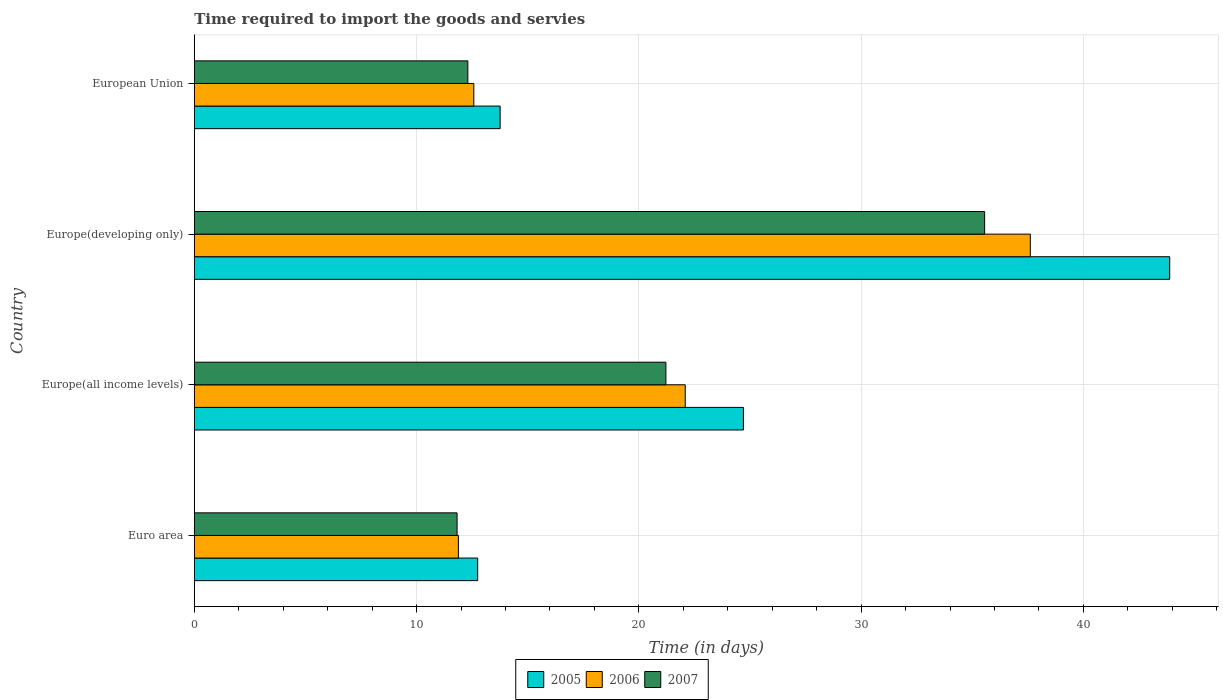Are the number of bars on each tick of the Y-axis equal?
Ensure brevity in your answer.  Yes. How many bars are there on the 1st tick from the bottom?
Your response must be concise. 3. What is the label of the 3rd group of bars from the top?
Your answer should be very brief. Europe(all income levels). In how many cases, is the number of bars for a given country not equal to the number of legend labels?
Provide a succinct answer. 0. What is the number of days required to import the goods and services in 2006 in Euro area?
Provide a succinct answer. 11.88. Across all countries, what is the maximum number of days required to import the goods and services in 2006?
Keep it short and to the point. 37.61. Across all countries, what is the minimum number of days required to import the goods and services in 2007?
Give a very brief answer. 11.82. In which country was the number of days required to import the goods and services in 2007 maximum?
Your answer should be very brief. Europe(developing only). In which country was the number of days required to import the goods and services in 2007 minimum?
Keep it short and to the point. Euro area. What is the total number of days required to import the goods and services in 2006 in the graph?
Provide a succinct answer. 84.16. What is the difference between the number of days required to import the goods and services in 2007 in Euro area and that in Europe(developing only)?
Offer a very short reply. -23.73. What is the difference between the number of days required to import the goods and services in 2006 in Euro area and the number of days required to import the goods and services in 2005 in Europe(all income levels)?
Your response must be concise. -12.82. What is the average number of days required to import the goods and services in 2005 per country?
Make the answer very short. 23.77. What is the difference between the number of days required to import the goods and services in 2007 and number of days required to import the goods and services in 2005 in European Union?
Give a very brief answer. -1.45. In how many countries, is the number of days required to import the goods and services in 2005 greater than 38 days?
Keep it short and to the point. 1. What is the ratio of the number of days required to import the goods and services in 2006 in Euro area to that in Europe(all income levels)?
Offer a terse response. 0.54. Is the difference between the number of days required to import the goods and services in 2007 in Europe(all income levels) and Europe(developing only) greater than the difference between the number of days required to import the goods and services in 2005 in Europe(all income levels) and Europe(developing only)?
Offer a terse response. Yes. What is the difference between the highest and the second highest number of days required to import the goods and services in 2007?
Your response must be concise. 14.34. What is the difference between the highest and the lowest number of days required to import the goods and services in 2005?
Your response must be concise. 31.13. In how many countries, is the number of days required to import the goods and services in 2006 greater than the average number of days required to import the goods and services in 2006 taken over all countries?
Make the answer very short. 2. What does the 3rd bar from the top in Euro area represents?
Provide a short and direct response. 2005. What does the 2nd bar from the bottom in Europe(developing only) represents?
Your answer should be very brief. 2006. Is it the case that in every country, the sum of the number of days required to import the goods and services in 2006 and number of days required to import the goods and services in 2007 is greater than the number of days required to import the goods and services in 2005?
Give a very brief answer. Yes. Are all the bars in the graph horizontal?
Offer a very short reply. Yes. How many countries are there in the graph?
Give a very brief answer. 4. Does the graph contain grids?
Provide a succinct answer. Yes. Where does the legend appear in the graph?
Your answer should be compact. Bottom center. What is the title of the graph?
Provide a succinct answer. Time required to import the goods and servies. Does "1982" appear as one of the legend labels in the graph?
Offer a terse response. No. What is the label or title of the X-axis?
Your response must be concise. Time (in days). What is the Time (in days) in 2005 in Euro area?
Keep it short and to the point. 12.75. What is the Time (in days) in 2006 in Euro area?
Offer a terse response. 11.88. What is the Time (in days) of 2007 in Euro area?
Your answer should be compact. 11.82. What is the Time (in days) of 2005 in Europe(all income levels)?
Offer a very short reply. 24.7. What is the Time (in days) in 2006 in Europe(all income levels)?
Give a very brief answer. 22.09. What is the Time (in days) in 2007 in Europe(all income levels)?
Make the answer very short. 21.22. What is the Time (in days) of 2005 in Europe(developing only)?
Provide a succinct answer. 43.88. What is the Time (in days) in 2006 in Europe(developing only)?
Make the answer very short. 37.61. What is the Time (in days) in 2007 in Europe(developing only)?
Provide a succinct answer. 35.56. What is the Time (in days) in 2005 in European Union?
Ensure brevity in your answer.  13.76. What is the Time (in days) in 2006 in European Union?
Your response must be concise. 12.58. What is the Time (in days) in 2007 in European Union?
Keep it short and to the point. 12.31. Across all countries, what is the maximum Time (in days) of 2005?
Make the answer very short. 43.88. Across all countries, what is the maximum Time (in days) in 2006?
Provide a succinct answer. 37.61. Across all countries, what is the maximum Time (in days) in 2007?
Make the answer very short. 35.56. Across all countries, what is the minimum Time (in days) of 2005?
Offer a terse response. 12.75. Across all countries, what is the minimum Time (in days) of 2006?
Your answer should be compact. 11.88. Across all countries, what is the minimum Time (in days) of 2007?
Your response must be concise. 11.82. What is the total Time (in days) of 2005 in the graph?
Keep it short and to the point. 95.1. What is the total Time (in days) in 2006 in the graph?
Offer a terse response. 84.16. What is the total Time (in days) in 2007 in the graph?
Your answer should be compact. 80.9. What is the difference between the Time (in days) in 2005 in Euro area and that in Europe(all income levels)?
Make the answer very short. -11.95. What is the difference between the Time (in days) in 2006 in Euro area and that in Europe(all income levels)?
Your answer should be compact. -10.2. What is the difference between the Time (in days) in 2007 in Euro area and that in Europe(all income levels)?
Provide a succinct answer. -9.39. What is the difference between the Time (in days) in 2005 in Euro area and that in Europe(developing only)?
Give a very brief answer. -31.13. What is the difference between the Time (in days) in 2006 in Euro area and that in Europe(developing only)?
Offer a terse response. -25.73. What is the difference between the Time (in days) of 2007 in Euro area and that in Europe(developing only)?
Your answer should be very brief. -23.73. What is the difference between the Time (in days) of 2005 in Euro area and that in European Union?
Keep it short and to the point. -1.01. What is the difference between the Time (in days) of 2006 in Euro area and that in European Union?
Offer a very short reply. -0.69. What is the difference between the Time (in days) in 2007 in Euro area and that in European Union?
Give a very brief answer. -0.48. What is the difference between the Time (in days) in 2005 in Europe(all income levels) and that in Europe(developing only)?
Your answer should be very brief. -19.18. What is the difference between the Time (in days) of 2006 in Europe(all income levels) and that in Europe(developing only)?
Offer a very short reply. -15.52. What is the difference between the Time (in days) of 2007 in Europe(all income levels) and that in Europe(developing only)?
Your answer should be compact. -14.34. What is the difference between the Time (in days) of 2005 in Europe(all income levels) and that in European Union?
Keep it short and to the point. 10.94. What is the difference between the Time (in days) of 2006 in Europe(all income levels) and that in European Union?
Your answer should be compact. 9.51. What is the difference between the Time (in days) of 2007 in Europe(all income levels) and that in European Union?
Keep it short and to the point. 8.91. What is the difference between the Time (in days) of 2005 in Europe(developing only) and that in European Union?
Give a very brief answer. 30.12. What is the difference between the Time (in days) in 2006 in Europe(developing only) and that in European Union?
Give a very brief answer. 25.03. What is the difference between the Time (in days) of 2007 in Europe(developing only) and that in European Union?
Keep it short and to the point. 23.25. What is the difference between the Time (in days) of 2005 in Euro area and the Time (in days) of 2006 in Europe(all income levels)?
Provide a succinct answer. -9.34. What is the difference between the Time (in days) of 2005 in Euro area and the Time (in days) of 2007 in Europe(all income levels)?
Keep it short and to the point. -8.47. What is the difference between the Time (in days) in 2006 in Euro area and the Time (in days) in 2007 in Europe(all income levels)?
Your answer should be very brief. -9.34. What is the difference between the Time (in days) of 2005 in Euro area and the Time (in days) of 2006 in Europe(developing only)?
Your answer should be compact. -24.86. What is the difference between the Time (in days) of 2005 in Euro area and the Time (in days) of 2007 in Europe(developing only)?
Give a very brief answer. -22.81. What is the difference between the Time (in days) of 2006 in Euro area and the Time (in days) of 2007 in Europe(developing only)?
Ensure brevity in your answer.  -23.67. What is the difference between the Time (in days) in 2005 in Euro area and the Time (in days) in 2006 in European Union?
Keep it short and to the point. 0.17. What is the difference between the Time (in days) in 2005 in Euro area and the Time (in days) in 2007 in European Union?
Provide a short and direct response. 0.44. What is the difference between the Time (in days) in 2006 in Euro area and the Time (in days) in 2007 in European Union?
Make the answer very short. -0.43. What is the difference between the Time (in days) of 2005 in Europe(all income levels) and the Time (in days) of 2006 in Europe(developing only)?
Keep it short and to the point. -12.91. What is the difference between the Time (in days) in 2005 in Europe(all income levels) and the Time (in days) in 2007 in Europe(developing only)?
Offer a terse response. -10.85. What is the difference between the Time (in days) of 2006 in Europe(all income levels) and the Time (in days) of 2007 in Europe(developing only)?
Your answer should be compact. -13.47. What is the difference between the Time (in days) of 2005 in Europe(all income levels) and the Time (in days) of 2006 in European Union?
Keep it short and to the point. 12.13. What is the difference between the Time (in days) in 2005 in Europe(all income levels) and the Time (in days) in 2007 in European Union?
Offer a terse response. 12.4. What is the difference between the Time (in days) in 2006 in Europe(all income levels) and the Time (in days) in 2007 in European Union?
Make the answer very short. 9.78. What is the difference between the Time (in days) of 2005 in Europe(developing only) and the Time (in days) of 2006 in European Union?
Ensure brevity in your answer.  31.31. What is the difference between the Time (in days) of 2005 in Europe(developing only) and the Time (in days) of 2007 in European Union?
Your answer should be compact. 31.57. What is the difference between the Time (in days) in 2006 in Europe(developing only) and the Time (in days) in 2007 in European Union?
Offer a terse response. 25.3. What is the average Time (in days) in 2005 per country?
Ensure brevity in your answer.  23.77. What is the average Time (in days) in 2006 per country?
Make the answer very short. 21.04. What is the average Time (in days) in 2007 per country?
Offer a terse response. 20.23. What is the difference between the Time (in days) in 2005 and Time (in days) in 2006 in Euro area?
Provide a succinct answer. 0.87. What is the difference between the Time (in days) in 2005 and Time (in days) in 2007 in Euro area?
Offer a very short reply. 0.93. What is the difference between the Time (in days) of 2006 and Time (in days) of 2007 in Euro area?
Provide a succinct answer. 0.06. What is the difference between the Time (in days) in 2005 and Time (in days) in 2006 in Europe(all income levels)?
Your response must be concise. 2.62. What is the difference between the Time (in days) of 2005 and Time (in days) of 2007 in Europe(all income levels)?
Offer a terse response. 3.49. What is the difference between the Time (in days) of 2006 and Time (in days) of 2007 in Europe(all income levels)?
Ensure brevity in your answer.  0.87. What is the difference between the Time (in days) in 2005 and Time (in days) in 2006 in Europe(developing only)?
Offer a very short reply. 6.27. What is the difference between the Time (in days) in 2005 and Time (in days) in 2007 in Europe(developing only)?
Provide a succinct answer. 8.33. What is the difference between the Time (in days) of 2006 and Time (in days) of 2007 in Europe(developing only)?
Keep it short and to the point. 2.06. What is the difference between the Time (in days) of 2005 and Time (in days) of 2006 in European Union?
Make the answer very short. 1.18. What is the difference between the Time (in days) in 2005 and Time (in days) in 2007 in European Union?
Make the answer very short. 1.45. What is the difference between the Time (in days) of 2006 and Time (in days) of 2007 in European Union?
Offer a very short reply. 0.27. What is the ratio of the Time (in days) in 2005 in Euro area to that in Europe(all income levels)?
Provide a short and direct response. 0.52. What is the ratio of the Time (in days) of 2006 in Euro area to that in Europe(all income levels)?
Provide a short and direct response. 0.54. What is the ratio of the Time (in days) of 2007 in Euro area to that in Europe(all income levels)?
Your answer should be compact. 0.56. What is the ratio of the Time (in days) of 2005 in Euro area to that in Europe(developing only)?
Provide a succinct answer. 0.29. What is the ratio of the Time (in days) in 2006 in Euro area to that in Europe(developing only)?
Your answer should be compact. 0.32. What is the ratio of the Time (in days) in 2007 in Euro area to that in Europe(developing only)?
Your response must be concise. 0.33. What is the ratio of the Time (in days) in 2005 in Euro area to that in European Union?
Provide a succinct answer. 0.93. What is the ratio of the Time (in days) in 2006 in Euro area to that in European Union?
Keep it short and to the point. 0.94. What is the ratio of the Time (in days) of 2007 in Euro area to that in European Union?
Give a very brief answer. 0.96. What is the ratio of the Time (in days) in 2005 in Europe(all income levels) to that in Europe(developing only)?
Your answer should be very brief. 0.56. What is the ratio of the Time (in days) of 2006 in Europe(all income levels) to that in Europe(developing only)?
Offer a terse response. 0.59. What is the ratio of the Time (in days) of 2007 in Europe(all income levels) to that in Europe(developing only)?
Keep it short and to the point. 0.6. What is the ratio of the Time (in days) in 2005 in Europe(all income levels) to that in European Union?
Provide a succinct answer. 1.8. What is the ratio of the Time (in days) in 2006 in Europe(all income levels) to that in European Union?
Keep it short and to the point. 1.76. What is the ratio of the Time (in days) of 2007 in Europe(all income levels) to that in European Union?
Provide a short and direct response. 1.72. What is the ratio of the Time (in days) of 2005 in Europe(developing only) to that in European Union?
Make the answer very short. 3.19. What is the ratio of the Time (in days) in 2006 in Europe(developing only) to that in European Union?
Give a very brief answer. 2.99. What is the ratio of the Time (in days) in 2007 in Europe(developing only) to that in European Union?
Give a very brief answer. 2.89. What is the difference between the highest and the second highest Time (in days) in 2005?
Offer a very short reply. 19.18. What is the difference between the highest and the second highest Time (in days) in 2006?
Ensure brevity in your answer.  15.52. What is the difference between the highest and the second highest Time (in days) in 2007?
Provide a succinct answer. 14.34. What is the difference between the highest and the lowest Time (in days) of 2005?
Keep it short and to the point. 31.13. What is the difference between the highest and the lowest Time (in days) of 2006?
Your answer should be compact. 25.73. What is the difference between the highest and the lowest Time (in days) of 2007?
Make the answer very short. 23.73. 